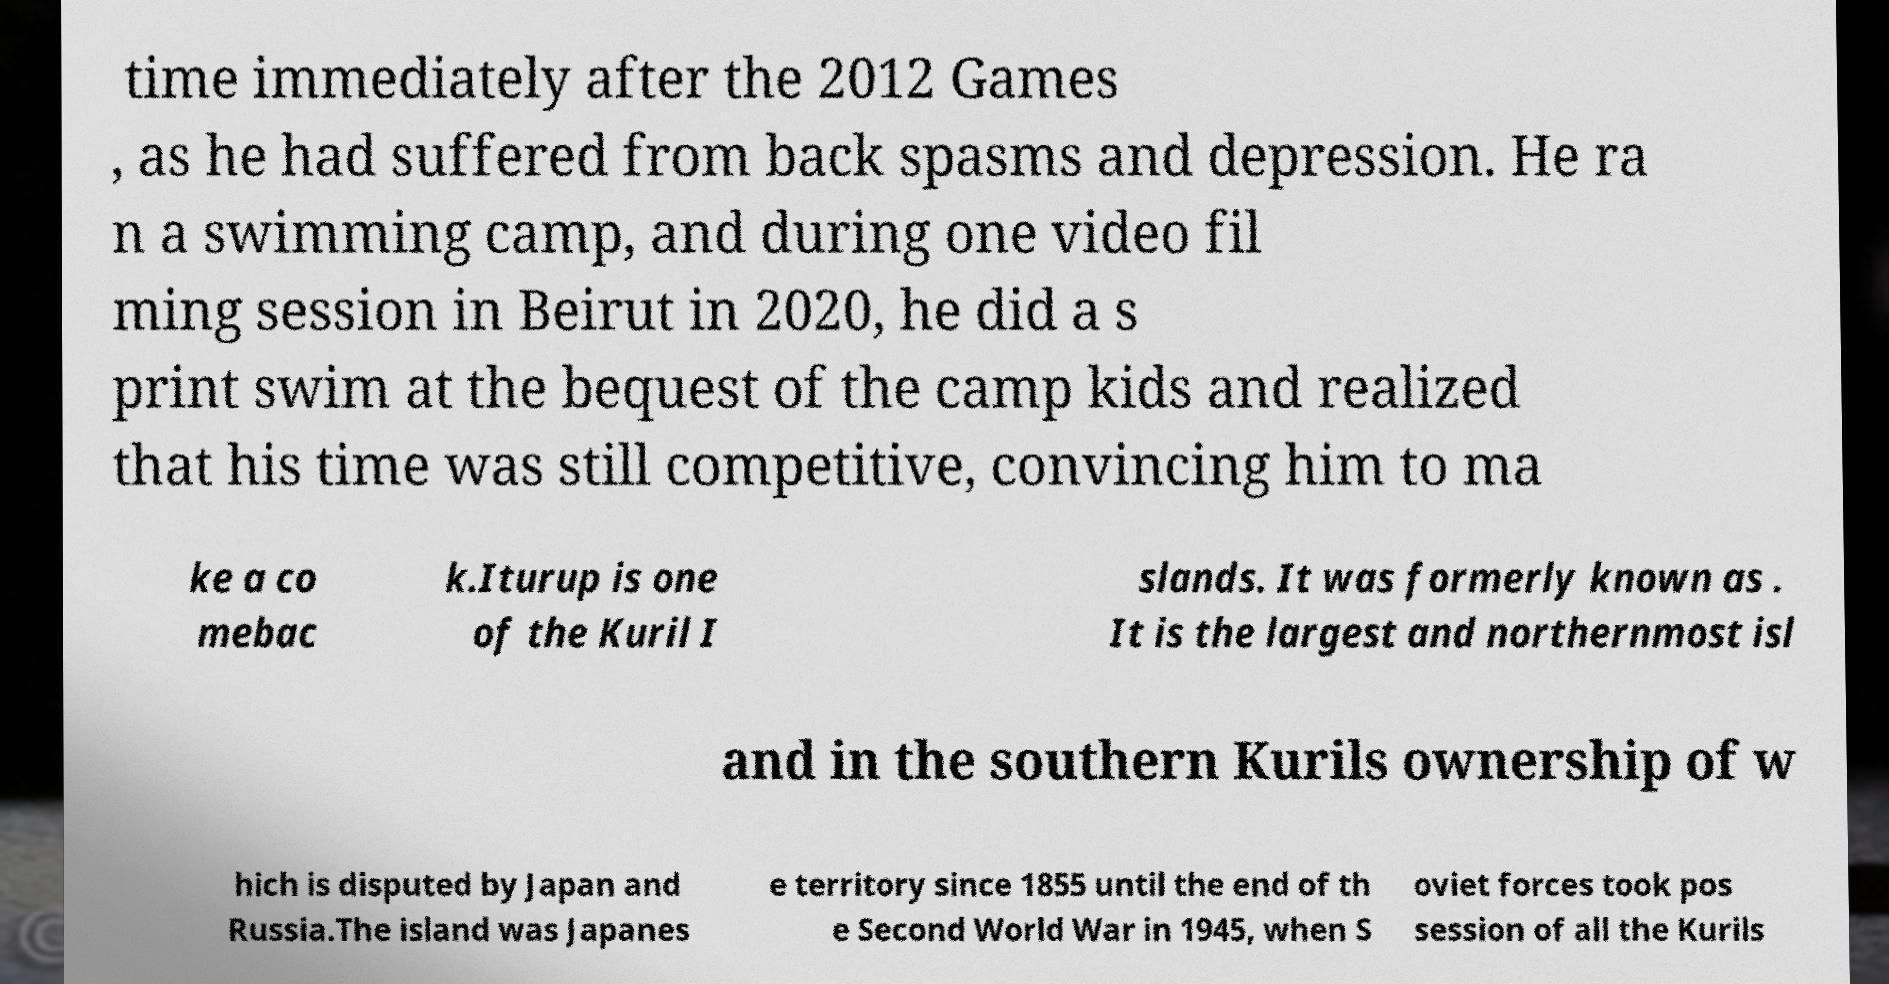There's text embedded in this image that I need extracted. Can you transcribe it verbatim? time immediately after the 2012 Games , as he had suffered from back spasms and depression. He ra n a swimming camp, and during one video fil ming session in Beirut in 2020, he did a s print swim at the bequest of the camp kids and realized that his time was still competitive, convincing him to ma ke a co mebac k.Iturup is one of the Kuril I slands. It was formerly known as . It is the largest and northernmost isl and in the southern Kurils ownership of w hich is disputed by Japan and Russia.The island was Japanes e territory since 1855 until the end of th e Second World War in 1945, when S oviet forces took pos session of all the Kurils 